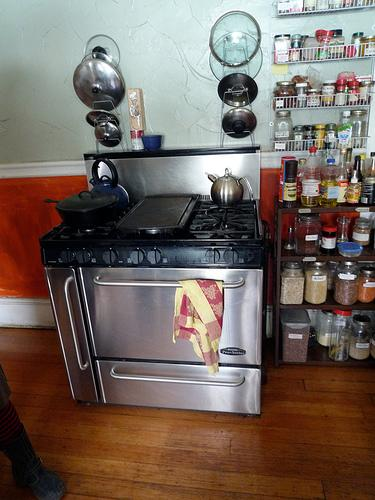What is next to the oven? Please explain your reasoning. spices. People use spices to cook.  they are kept in bottles and jars. 